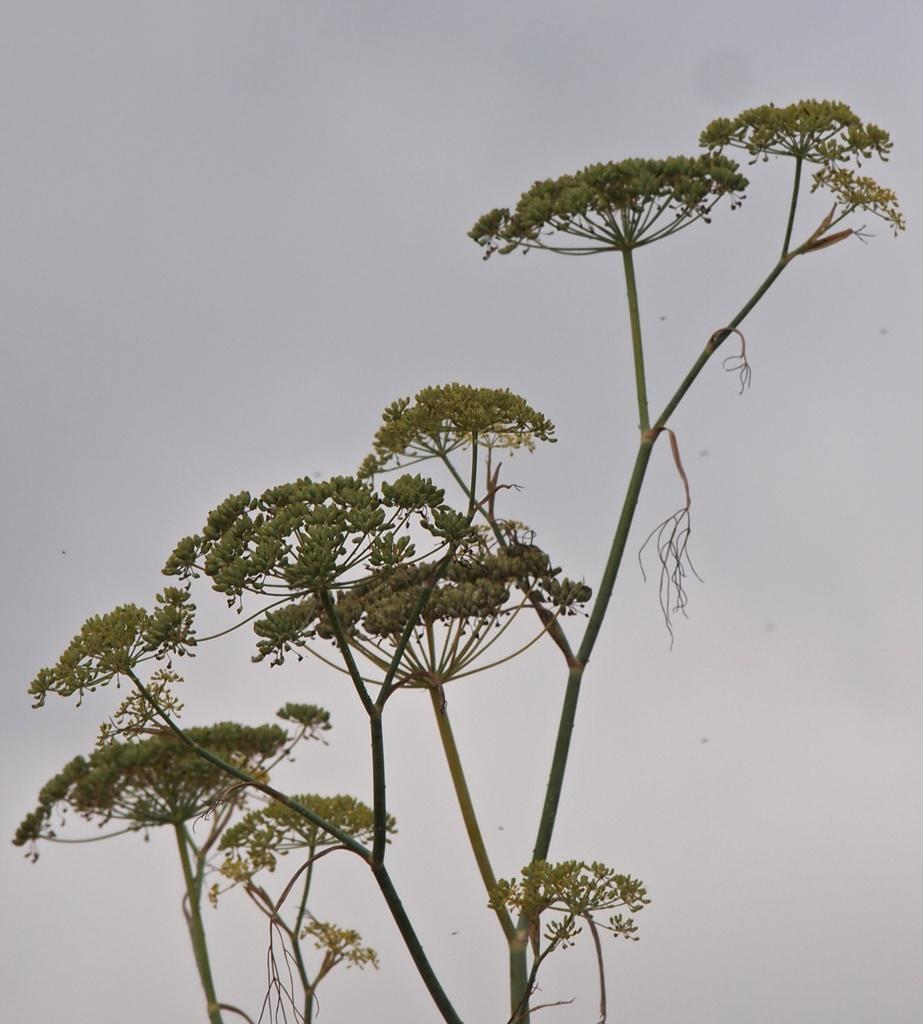What type of vegetation is present in the image? There are green leaves and stems in the image. What color is the background of the image? The background of the image is white. How does the balloon affect the movement of the leaves in the image? There is no balloon present in the image, so its effect on the leaves cannot be determined. 